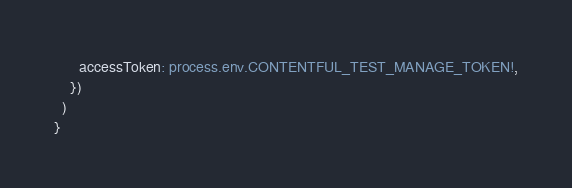Convert code to text. <code><loc_0><loc_0><loc_500><loc_500><_TypeScript_>      accessToken: process.env.CONTENTFUL_TEST_MANAGE_TOKEN!,
    })
  )
}
</code> 